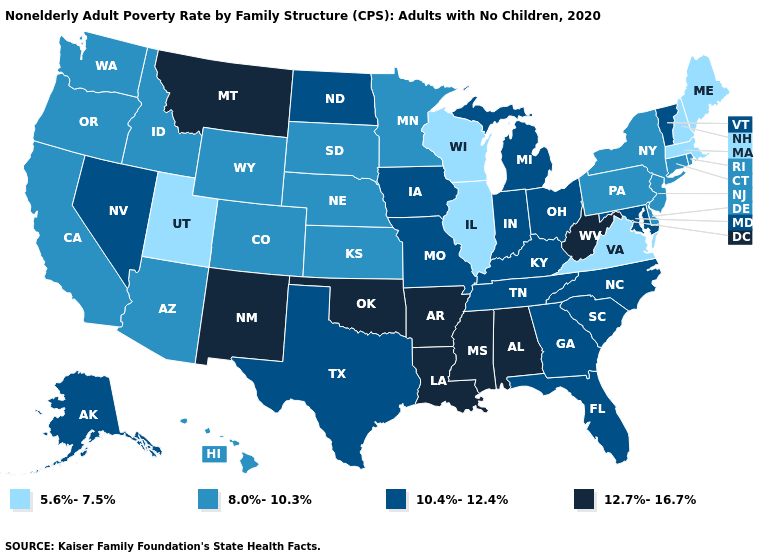Name the states that have a value in the range 8.0%-10.3%?
Answer briefly. Arizona, California, Colorado, Connecticut, Delaware, Hawaii, Idaho, Kansas, Minnesota, Nebraska, New Jersey, New York, Oregon, Pennsylvania, Rhode Island, South Dakota, Washington, Wyoming. Name the states that have a value in the range 12.7%-16.7%?
Keep it brief. Alabama, Arkansas, Louisiana, Mississippi, Montana, New Mexico, Oklahoma, West Virginia. What is the highest value in the USA?
Be succinct. 12.7%-16.7%. Which states have the highest value in the USA?
Quick response, please. Alabama, Arkansas, Louisiana, Mississippi, Montana, New Mexico, Oklahoma, West Virginia. What is the value of South Carolina?
Keep it brief. 10.4%-12.4%. What is the highest value in the USA?
Be succinct. 12.7%-16.7%. Which states have the highest value in the USA?
Concise answer only. Alabama, Arkansas, Louisiana, Mississippi, Montana, New Mexico, Oklahoma, West Virginia. Name the states that have a value in the range 12.7%-16.7%?
Keep it brief. Alabama, Arkansas, Louisiana, Mississippi, Montana, New Mexico, Oklahoma, West Virginia. Name the states that have a value in the range 10.4%-12.4%?
Answer briefly. Alaska, Florida, Georgia, Indiana, Iowa, Kentucky, Maryland, Michigan, Missouri, Nevada, North Carolina, North Dakota, Ohio, South Carolina, Tennessee, Texas, Vermont. Does Hawaii have a higher value than Minnesota?
Quick response, please. No. Does Iowa have the same value as Mississippi?
Write a very short answer. No. Which states have the lowest value in the USA?
Keep it brief. Illinois, Maine, Massachusetts, New Hampshire, Utah, Virginia, Wisconsin. What is the value of Wisconsin?
Keep it brief. 5.6%-7.5%. Name the states that have a value in the range 12.7%-16.7%?
Concise answer only. Alabama, Arkansas, Louisiana, Mississippi, Montana, New Mexico, Oklahoma, West Virginia. What is the highest value in states that border South Dakota?
Keep it brief. 12.7%-16.7%. 